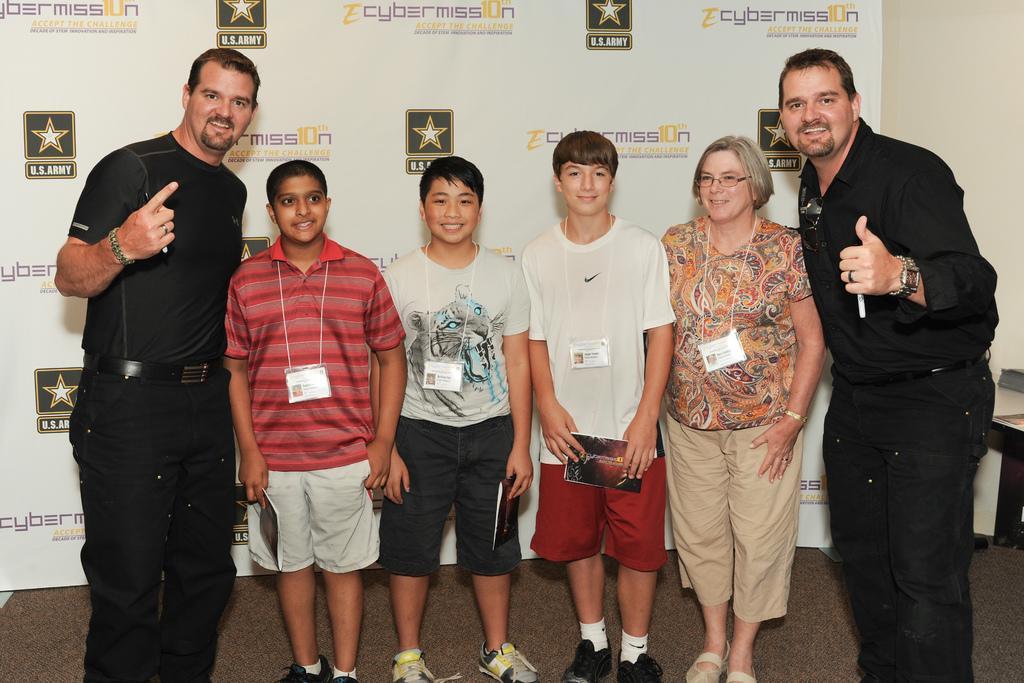Please provide a concise description of this image. In the image we can see two men, a woman and three children standing, they are wearing clothes and they are smiling. The two men are wearing wrist watches and finger rings. The woman is wearing spectacles, bracelet and identity card. The children are wearing shoes and identity cards. Behind them there is a poster and text on it. 